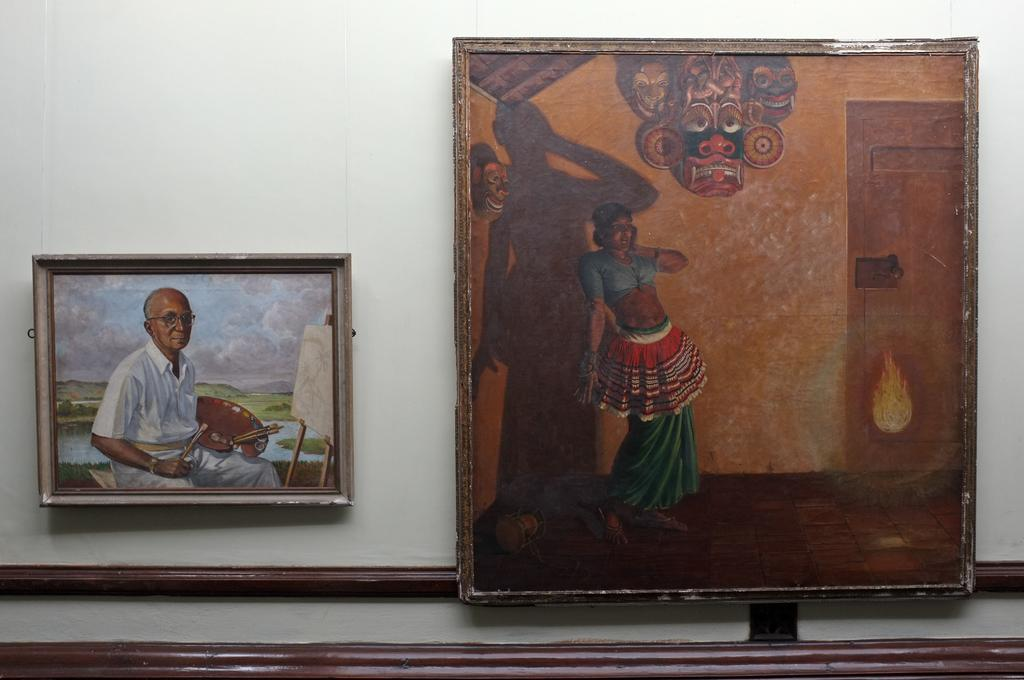How many photo frames can be seen in the image? There are two photo frames in the image. Where are the photo frames located? The photo frames are attached to the wall. What type of cactus is positioned next to the photo frames in the image? There is no cactus present in the image. What position does the cook hold in the image? There is no cook present in the image. 